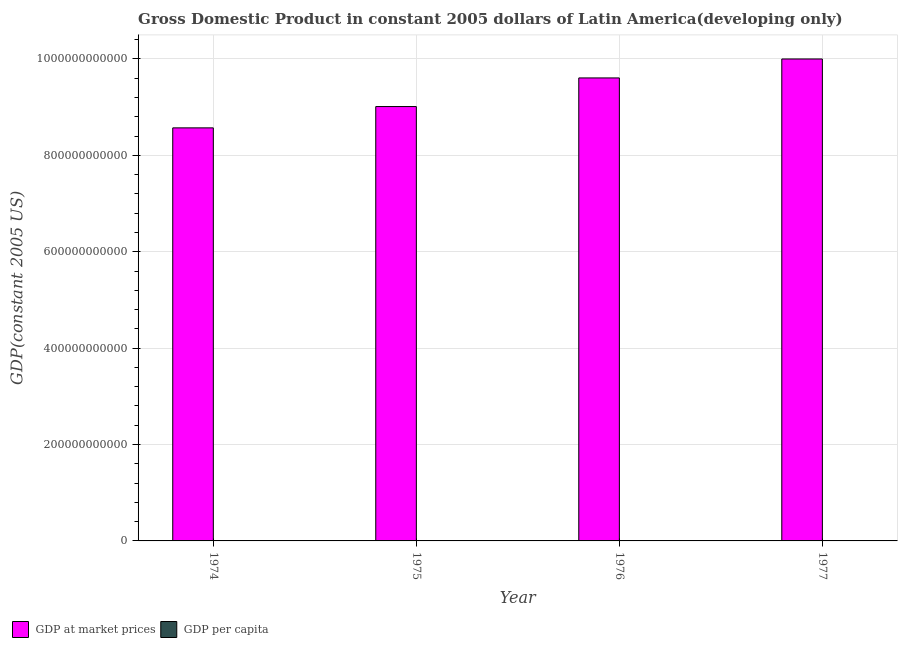How many bars are there on the 3rd tick from the left?
Make the answer very short. 2. How many bars are there on the 1st tick from the right?
Provide a succinct answer. 2. What is the label of the 1st group of bars from the left?
Make the answer very short. 1974. In how many cases, is the number of bars for a given year not equal to the number of legend labels?
Your answer should be compact. 0. What is the gdp at market prices in 1974?
Provide a short and direct response. 8.57e+11. Across all years, what is the maximum gdp per capita?
Make the answer very short. 3559.54. Across all years, what is the minimum gdp at market prices?
Provide a succinct answer. 8.57e+11. In which year was the gdp per capita maximum?
Provide a succinct answer. 1977. In which year was the gdp per capita minimum?
Offer a terse response. 1974. What is the total gdp at market prices in the graph?
Offer a terse response. 3.72e+12. What is the difference between the gdp at market prices in 1974 and that in 1976?
Your answer should be compact. -1.04e+11. What is the difference between the gdp per capita in 1974 and the gdp at market prices in 1975?
Offer a very short reply. -84.38. What is the average gdp at market prices per year?
Your response must be concise. 9.30e+11. In the year 1976, what is the difference between the gdp at market prices and gdp per capita?
Provide a succinct answer. 0. In how many years, is the gdp at market prices greater than 320000000000 US$?
Give a very brief answer. 4. What is the ratio of the gdp per capita in 1976 to that in 1977?
Make the answer very short. 0.98. Is the gdp at market prices in 1974 less than that in 1975?
Give a very brief answer. Yes. What is the difference between the highest and the second highest gdp per capita?
Your answer should be compact. 56.16. What is the difference between the highest and the lowest gdp at market prices?
Offer a very short reply. 1.43e+11. In how many years, is the gdp at market prices greater than the average gdp at market prices taken over all years?
Make the answer very short. 2. Is the sum of the gdp per capita in 1974 and 1977 greater than the maximum gdp at market prices across all years?
Your answer should be very brief. Yes. What does the 1st bar from the left in 1976 represents?
Give a very brief answer. GDP at market prices. What does the 1st bar from the right in 1977 represents?
Give a very brief answer. GDP per capita. Are all the bars in the graph horizontal?
Ensure brevity in your answer.  No. How many years are there in the graph?
Ensure brevity in your answer.  4. What is the difference between two consecutive major ticks on the Y-axis?
Keep it short and to the point. 2.00e+11. Are the values on the major ticks of Y-axis written in scientific E-notation?
Offer a terse response. No. Where does the legend appear in the graph?
Make the answer very short. Bottom left. How many legend labels are there?
Offer a terse response. 2. What is the title of the graph?
Your response must be concise. Gross Domestic Product in constant 2005 dollars of Latin America(developing only). What is the label or title of the X-axis?
Ensure brevity in your answer.  Year. What is the label or title of the Y-axis?
Provide a short and direct response. GDP(constant 2005 US). What is the GDP(constant 2005 US) in GDP at market prices in 1974?
Your answer should be very brief. 8.57e+11. What is the GDP(constant 2005 US) in GDP per capita in 1974?
Provide a short and direct response. 3284.22. What is the GDP(constant 2005 US) of GDP at market prices in 1975?
Offer a terse response. 9.01e+11. What is the GDP(constant 2005 US) in GDP per capita in 1975?
Ensure brevity in your answer.  3368.6. What is the GDP(constant 2005 US) of GDP at market prices in 1976?
Keep it short and to the point. 9.61e+11. What is the GDP(constant 2005 US) in GDP per capita in 1976?
Offer a very short reply. 3503.38. What is the GDP(constant 2005 US) in GDP at market prices in 1977?
Provide a succinct answer. 1.00e+12. What is the GDP(constant 2005 US) of GDP per capita in 1977?
Your answer should be compact. 3559.54. Across all years, what is the maximum GDP(constant 2005 US) of GDP at market prices?
Keep it short and to the point. 1.00e+12. Across all years, what is the maximum GDP(constant 2005 US) of GDP per capita?
Provide a short and direct response. 3559.54. Across all years, what is the minimum GDP(constant 2005 US) in GDP at market prices?
Your response must be concise. 8.57e+11. Across all years, what is the minimum GDP(constant 2005 US) of GDP per capita?
Ensure brevity in your answer.  3284.22. What is the total GDP(constant 2005 US) of GDP at market prices in the graph?
Keep it short and to the point. 3.72e+12. What is the total GDP(constant 2005 US) in GDP per capita in the graph?
Ensure brevity in your answer.  1.37e+04. What is the difference between the GDP(constant 2005 US) of GDP at market prices in 1974 and that in 1975?
Provide a short and direct response. -4.42e+1. What is the difference between the GDP(constant 2005 US) in GDP per capita in 1974 and that in 1975?
Your answer should be very brief. -84.38. What is the difference between the GDP(constant 2005 US) of GDP at market prices in 1974 and that in 1976?
Offer a very short reply. -1.04e+11. What is the difference between the GDP(constant 2005 US) of GDP per capita in 1974 and that in 1976?
Provide a short and direct response. -219.16. What is the difference between the GDP(constant 2005 US) in GDP at market prices in 1974 and that in 1977?
Make the answer very short. -1.43e+11. What is the difference between the GDP(constant 2005 US) in GDP per capita in 1974 and that in 1977?
Keep it short and to the point. -275.32. What is the difference between the GDP(constant 2005 US) in GDP at market prices in 1975 and that in 1976?
Keep it short and to the point. -5.94e+1. What is the difference between the GDP(constant 2005 US) in GDP per capita in 1975 and that in 1976?
Your answer should be very brief. -134.77. What is the difference between the GDP(constant 2005 US) of GDP at market prices in 1975 and that in 1977?
Give a very brief answer. -9.87e+1. What is the difference between the GDP(constant 2005 US) in GDP per capita in 1975 and that in 1977?
Offer a very short reply. -190.93. What is the difference between the GDP(constant 2005 US) in GDP at market prices in 1976 and that in 1977?
Offer a terse response. -3.93e+1. What is the difference between the GDP(constant 2005 US) of GDP per capita in 1976 and that in 1977?
Your response must be concise. -56.16. What is the difference between the GDP(constant 2005 US) of GDP at market prices in 1974 and the GDP(constant 2005 US) of GDP per capita in 1975?
Provide a short and direct response. 8.57e+11. What is the difference between the GDP(constant 2005 US) of GDP at market prices in 1974 and the GDP(constant 2005 US) of GDP per capita in 1976?
Make the answer very short. 8.57e+11. What is the difference between the GDP(constant 2005 US) of GDP at market prices in 1974 and the GDP(constant 2005 US) of GDP per capita in 1977?
Offer a terse response. 8.57e+11. What is the difference between the GDP(constant 2005 US) of GDP at market prices in 1975 and the GDP(constant 2005 US) of GDP per capita in 1976?
Offer a terse response. 9.01e+11. What is the difference between the GDP(constant 2005 US) in GDP at market prices in 1975 and the GDP(constant 2005 US) in GDP per capita in 1977?
Give a very brief answer. 9.01e+11. What is the difference between the GDP(constant 2005 US) in GDP at market prices in 1976 and the GDP(constant 2005 US) in GDP per capita in 1977?
Your response must be concise. 9.61e+11. What is the average GDP(constant 2005 US) of GDP at market prices per year?
Offer a very short reply. 9.30e+11. What is the average GDP(constant 2005 US) in GDP per capita per year?
Offer a very short reply. 3428.93. In the year 1974, what is the difference between the GDP(constant 2005 US) in GDP at market prices and GDP(constant 2005 US) in GDP per capita?
Your answer should be compact. 8.57e+11. In the year 1975, what is the difference between the GDP(constant 2005 US) in GDP at market prices and GDP(constant 2005 US) in GDP per capita?
Offer a very short reply. 9.01e+11. In the year 1976, what is the difference between the GDP(constant 2005 US) in GDP at market prices and GDP(constant 2005 US) in GDP per capita?
Keep it short and to the point. 9.61e+11. In the year 1977, what is the difference between the GDP(constant 2005 US) of GDP at market prices and GDP(constant 2005 US) of GDP per capita?
Your answer should be very brief. 1.00e+12. What is the ratio of the GDP(constant 2005 US) of GDP at market prices in 1974 to that in 1975?
Keep it short and to the point. 0.95. What is the ratio of the GDP(constant 2005 US) in GDP per capita in 1974 to that in 1975?
Make the answer very short. 0.97. What is the ratio of the GDP(constant 2005 US) in GDP at market prices in 1974 to that in 1976?
Keep it short and to the point. 0.89. What is the ratio of the GDP(constant 2005 US) in GDP per capita in 1974 to that in 1976?
Give a very brief answer. 0.94. What is the ratio of the GDP(constant 2005 US) of GDP at market prices in 1974 to that in 1977?
Your answer should be very brief. 0.86. What is the ratio of the GDP(constant 2005 US) of GDP per capita in 1974 to that in 1977?
Offer a terse response. 0.92. What is the ratio of the GDP(constant 2005 US) of GDP at market prices in 1975 to that in 1976?
Offer a very short reply. 0.94. What is the ratio of the GDP(constant 2005 US) of GDP per capita in 1975 to that in 1976?
Keep it short and to the point. 0.96. What is the ratio of the GDP(constant 2005 US) in GDP at market prices in 1975 to that in 1977?
Your response must be concise. 0.9. What is the ratio of the GDP(constant 2005 US) of GDP per capita in 1975 to that in 1977?
Give a very brief answer. 0.95. What is the ratio of the GDP(constant 2005 US) in GDP at market prices in 1976 to that in 1977?
Offer a terse response. 0.96. What is the ratio of the GDP(constant 2005 US) of GDP per capita in 1976 to that in 1977?
Offer a terse response. 0.98. What is the difference between the highest and the second highest GDP(constant 2005 US) of GDP at market prices?
Your response must be concise. 3.93e+1. What is the difference between the highest and the second highest GDP(constant 2005 US) in GDP per capita?
Keep it short and to the point. 56.16. What is the difference between the highest and the lowest GDP(constant 2005 US) in GDP at market prices?
Your response must be concise. 1.43e+11. What is the difference between the highest and the lowest GDP(constant 2005 US) of GDP per capita?
Offer a very short reply. 275.32. 